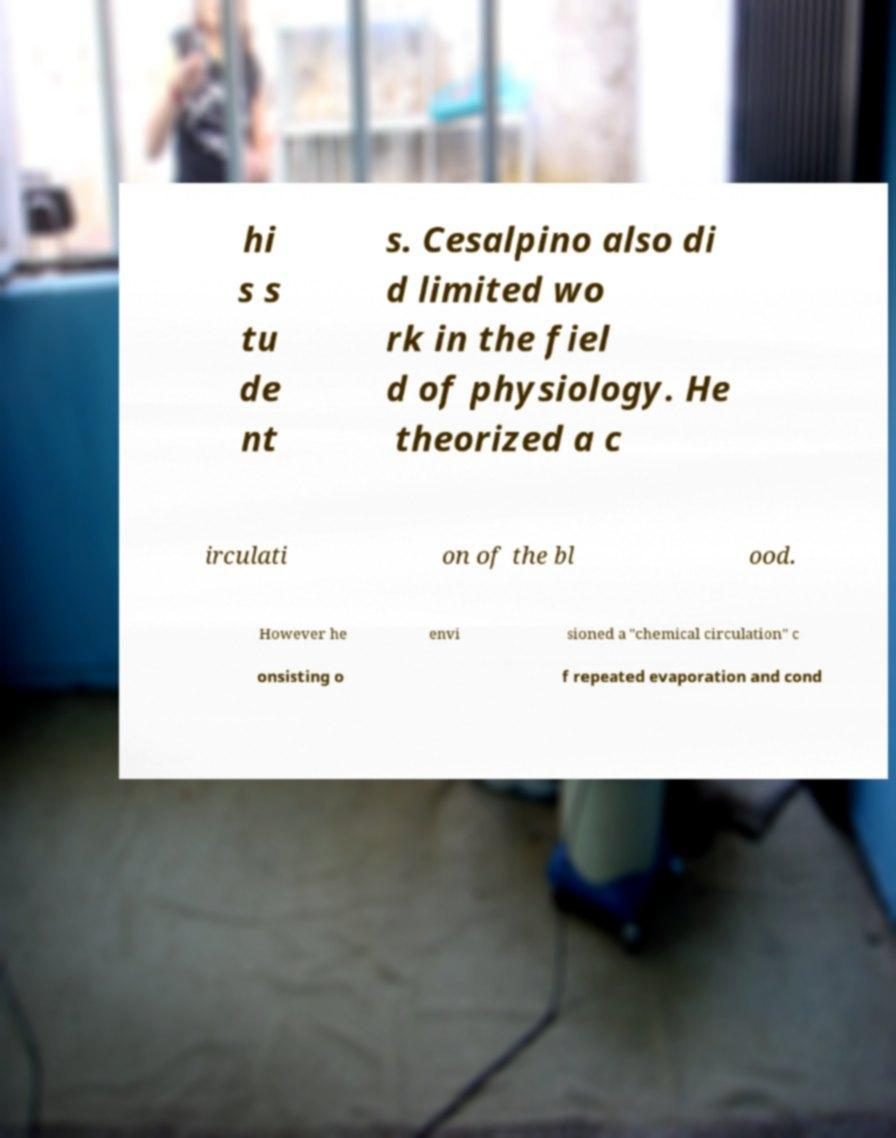For documentation purposes, I need the text within this image transcribed. Could you provide that? hi s s tu de nt s. Cesalpino also di d limited wo rk in the fiel d of physiology. He theorized a c irculati on of the bl ood. However he envi sioned a "chemical circulation" c onsisting o f repeated evaporation and cond 